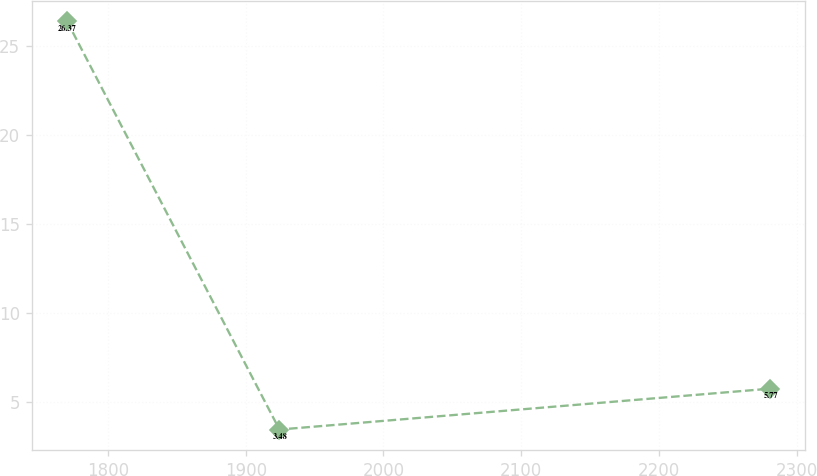Convert chart. <chart><loc_0><loc_0><loc_500><loc_500><line_chart><ecel><fcel>Unnamed: 1<nl><fcel>1770.19<fcel>26.37<nl><fcel>1924.48<fcel>3.48<nl><fcel>2280.78<fcel>5.77<nl></chart> 